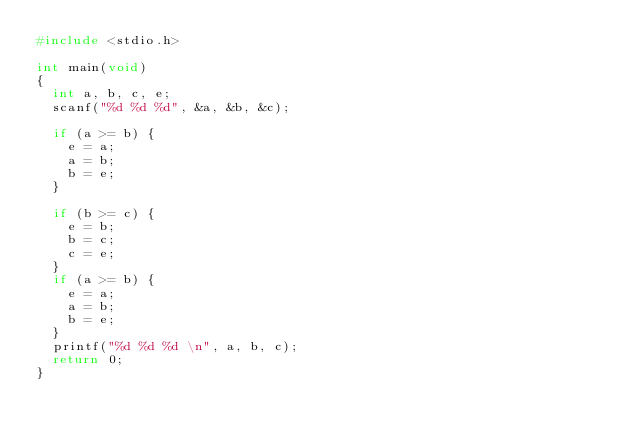Convert code to text. <code><loc_0><loc_0><loc_500><loc_500><_C_>#include <stdio.h>

int main(void)
{
	int a, b, c, e;
	scanf("%d %d %d", &a, &b, &c);

	if (a >= b) {
		e = a;
		a = b;
		b = e;
	}

	if (b >= c) {
		e = b;
		b = c;
		c = e;
	}
	if (a >= b) {
		e = a;
		a = b;
		b = e;
	}
	printf("%d %d %d \n", a, b, c);
	return 0;
}
</code> 